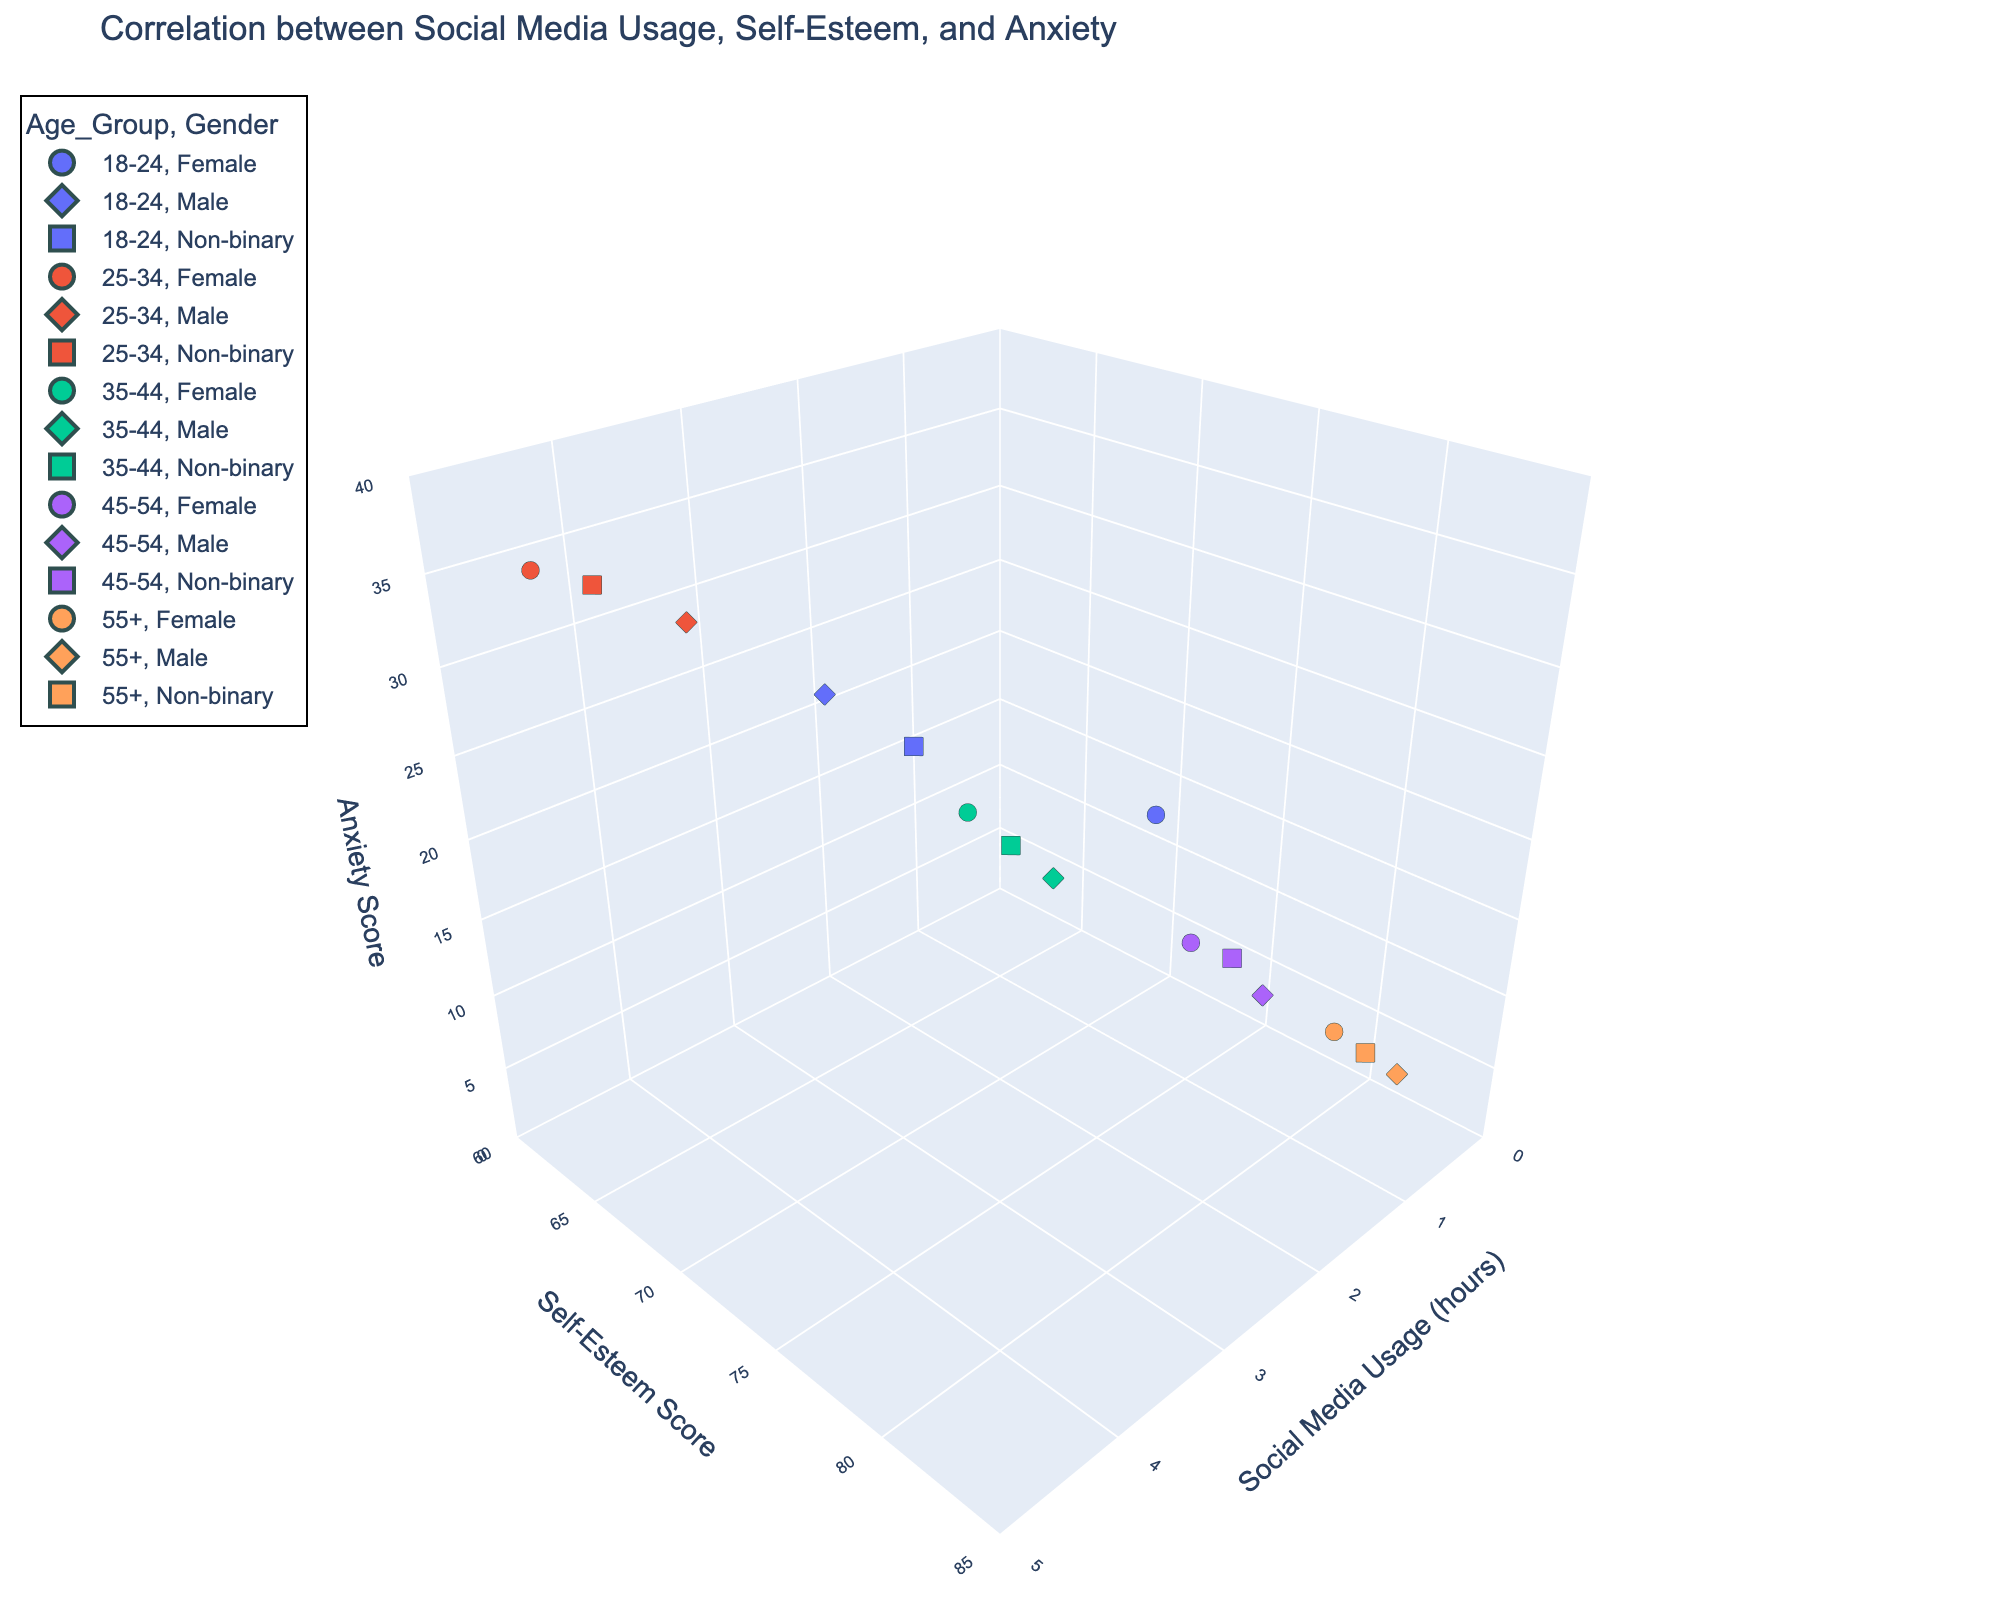What is the title of the plot? The title is generally found at the top of the plot and provides an overview of what the plot is representing.
Answer: Correlation between Social Media Usage, Self-Esteem, and Anxiety What are the axis titles of the plot? Axis titles help identify what each axis represents in the plot. The x-axis, y-axis, and z-axis titles indicate the variables measured along each axis.
Answer: Social Media Usage (hours), Self-Esteem Score, Anxiety Score Which age group appears to have the highest self-esteem scores? By examining the y-axis, we can identify the age group whose data points are located at the higher end of the self-esteem score range.
Answer: 55+ For the age group 18-24, how does the social media usage differ between females and males? We compare the x-axis values of the data points corresponding to females and males within the 18-24 age group.
Answer: Females typically use social media less than males in this group Which demographic group has the highest anxiety score? By looking at the z-axis values, find the data point with the highest anxiety score, then identify the corresponding demographic details from the plot.
Answer: Females in the 25-34 age group What is the range of social media usage (in hours) that appears on the x-axis? The x-axis range can be directly observed from the plot, showing the minimum and maximum values.
Answer: 0 to 5 hours Do non-binary individuals in the 35-44 age group have higher or lower self-esteem scores compared to their male counterparts? Compare the y-axis values (self-esteem scores) for non-binary and male individuals within the 35-44 age group.
Answer: Lower What is the difference in anxiety scores between the male and non-binary genders in the 55+ age group? Subtract the anxiety score of one gender from the other within the same age group based on their positions along the z-axis.
Answer: 1 (Male: 8, Non-binary: 9) Between the 25-34 and 45-54 age groups, which has a wider spread of self-esteem scores? Compare the range (highest - lowest) of self-esteem scores (y-axis) between the two age groups.
Answer: 25-34 age group has a wider spread In general, how does social media usage correlate with anxiety scores? By observing the trends in the 3D scatter plot, determine if higher social media usage is often associated with higher or lower anxiety scores.
Answer: Generally, higher social media usage correlates with higher anxiety scores 